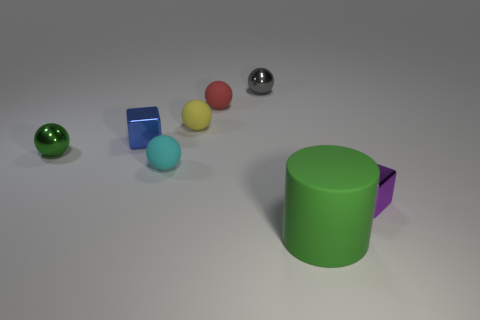How many objects are either tiny yellow cubes or red matte balls?
Give a very brief answer. 1. Are there any big red objects of the same shape as the gray metallic thing?
Offer a very short reply. No. There is a tiny cube right of the gray metal sphere; is its color the same as the big cylinder?
Offer a very short reply. No. What is the shape of the shiny object that is on the left side of the small block to the left of the purple metal block?
Offer a terse response. Sphere. Are there any blue shiny objects that have the same size as the cyan rubber object?
Your response must be concise. Yes. Are there fewer large brown spheres than green matte objects?
Your response must be concise. Yes. The tiny object that is on the left side of the tiny block on the left side of the cube that is right of the tiny blue metallic block is what shape?
Ensure brevity in your answer.  Sphere. How many things are tiny metal things that are behind the small green metal sphere or tiny metal balls that are to the left of the small blue shiny cube?
Offer a very short reply. 3. There is a blue metal cube; are there any small gray shiny spheres left of it?
Make the answer very short. No. How many objects are either green things on the left side of the matte cylinder or small cyan metallic cylinders?
Give a very brief answer. 1. 